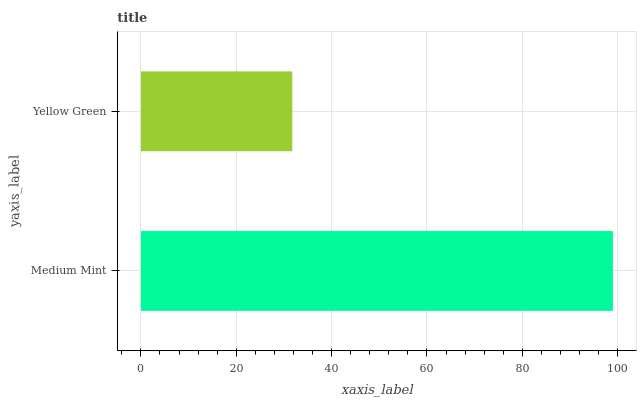Is Yellow Green the minimum?
Answer yes or no. Yes. Is Medium Mint the maximum?
Answer yes or no. Yes. Is Yellow Green the maximum?
Answer yes or no. No. Is Medium Mint greater than Yellow Green?
Answer yes or no. Yes. Is Yellow Green less than Medium Mint?
Answer yes or no. Yes. Is Yellow Green greater than Medium Mint?
Answer yes or no. No. Is Medium Mint less than Yellow Green?
Answer yes or no. No. Is Medium Mint the high median?
Answer yes or no. Yes. Is Yellow Green the low median?
Answer yes or no. Yes. Is Yellow Green the high median?
Answer yes or no. No. Is Medium Mint the low median?
Answer yes or no. No. 